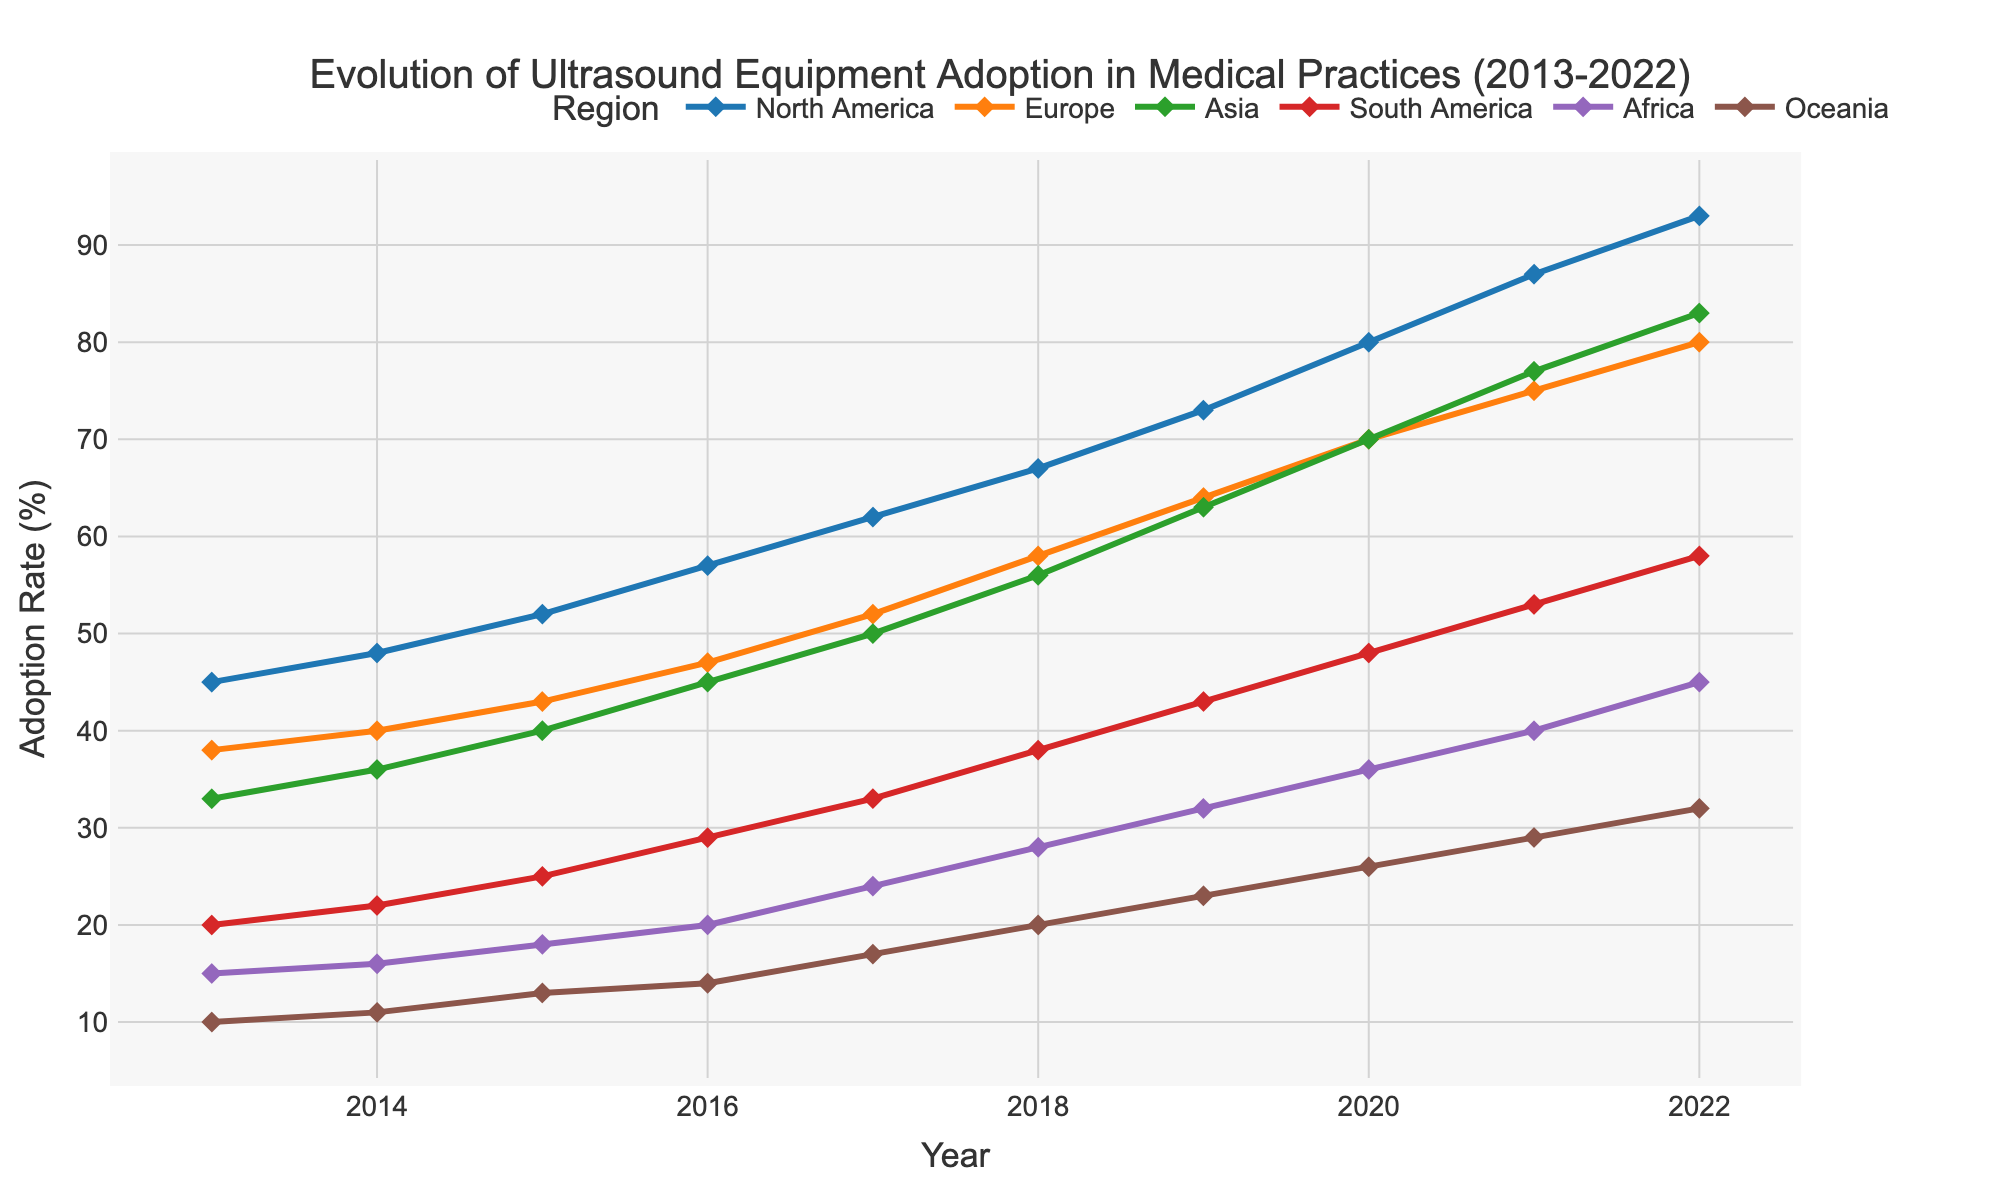What's the title of the plot? The title is stated at the top of the figure.
Answer: Evolution of Ultrasound Equipment Adoption in Medical Practices (2013-2022) What is the adoption rate for North America in 2020? Locate the 'North America' line on the plot and follow it to the year 2020 on the x-axis. The corresponding y-axis value shows the adoption rate.
Answer: 80% Which year shows the maximum adoption rate for Asia? Identify the 'Asia' line on the plot and find the highest point along this line. Then, check the x-axis to find the corresponding year.
Answer: 2022 How many regions are represented in the plot? Count the number of unique lines or legend entries in the figure.
Answer: 6 What is the trend of ultrasound equipment adoption in Africa from 2018 to 2022? Follow the 'Africa' line from the year 2018 to 2022. Compare the values at these endpoints and note whether there is an increase, decrease, or no change.
Answer: Increasing By how much did the adoption rate in Europe increase from 2013 to 2022? Check the adoption rate for Europe in 2013 and in 2022, then compute the difference between the two values. 80 - 38 = 42.
Answer: 42% In which year did South America have an adoption rate of approximately 43%? Follow the 'South America' line and identify the year where it intersects with the 43% mark on the y-axis.
Answer: 2019 Which region saw the most significant increase in adoption rate from 2013 to 2022? Calculate the difference in adoption rates from 2013 to 2022 for each region and compare these differences to determine the largest one.
Answer: North America Compare the adoption rate in Oceania between 2013 and 2018. What is the percentage increase? Find the adoption rate for Oceania in 2013 and in 2018, then compute the percentage increase: ((20 - 10) / 10) * 100 = 100%.
Answer: 100% What can be inferred about the adoption rate trend in all regions over the last decade? Look at each line and note the general direction and pattern from 2013 to 2022.
Answer: Increasing in all regions 